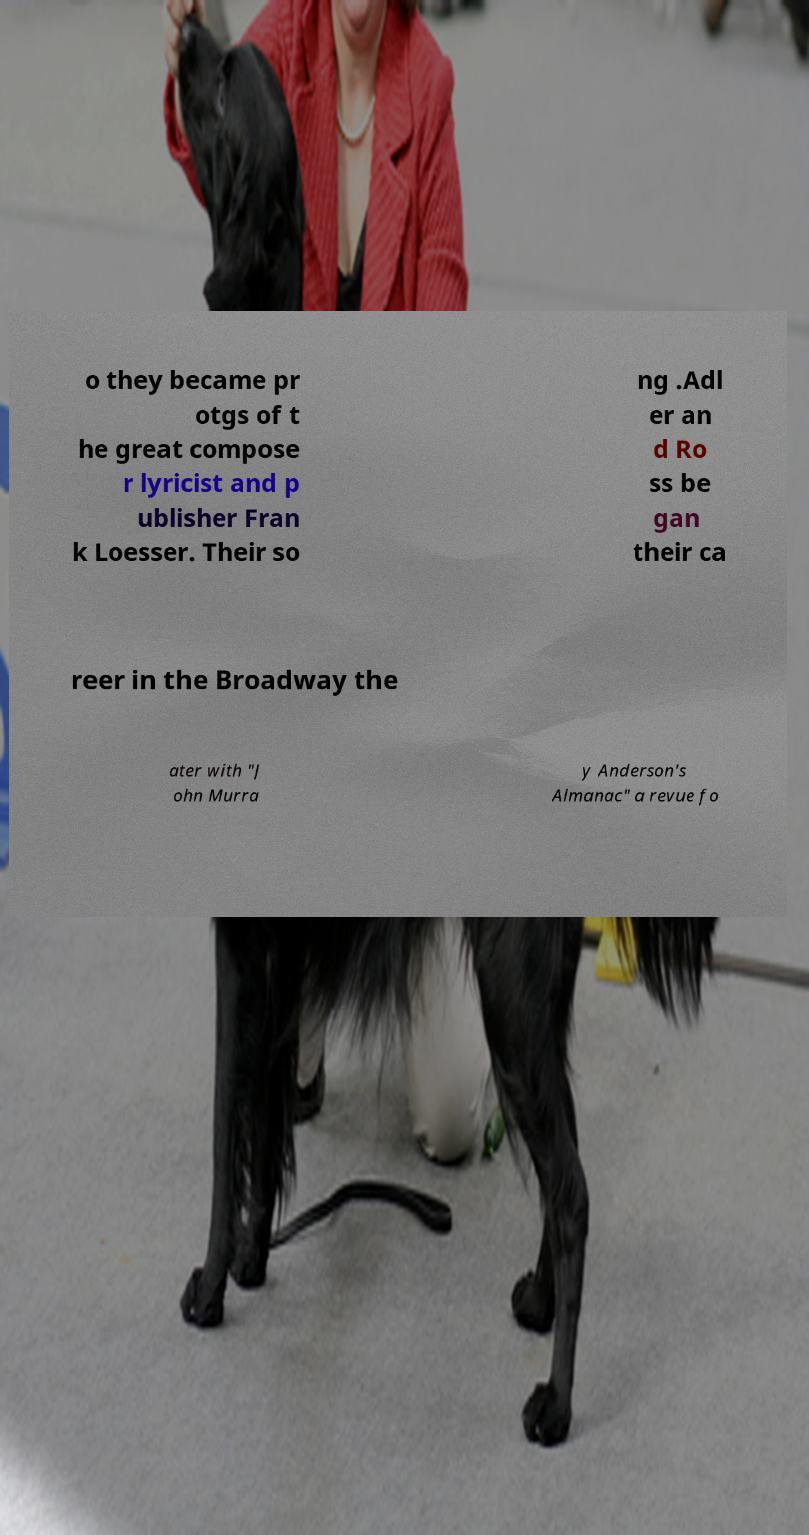Can you accurately transcribe the text from the provided image for me? o they became pr otgs of t he great compose r lyricist and p ublisher Fran k Loesser. Their so ng .Adl er an d Ro ss be gan their ca reer in the Broadway the ater with "J ohn Murra y Anderson's Almanac" a revue fo 